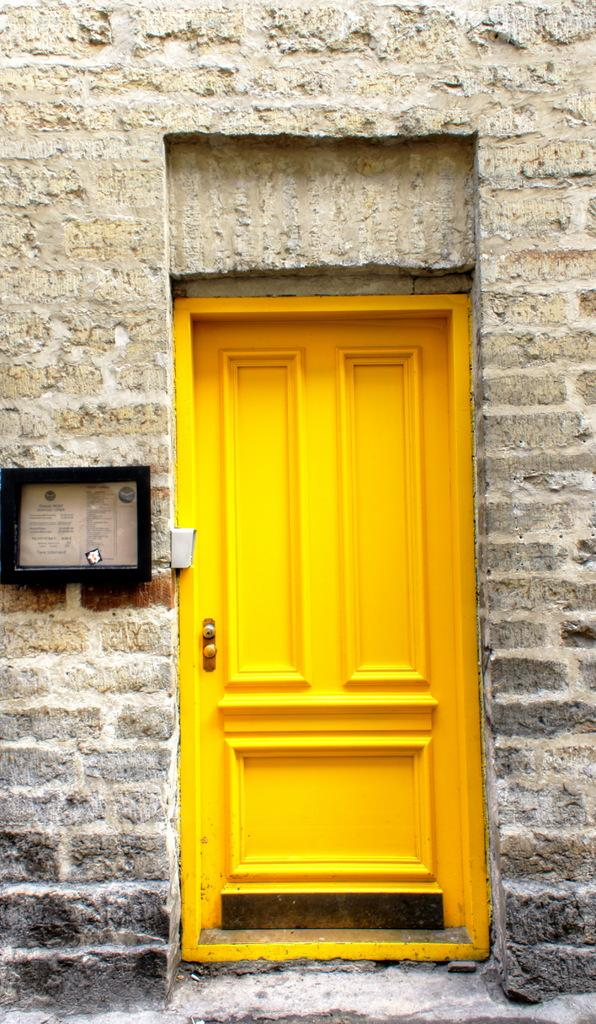What is the color and material of the door in the image? The door is a yellow color wooden door. What is the door attached to in the image? The door is attached to a brick wall. What can be seen on the wall next to the door? There is a black color box on the wall. What is inside the black box? The box contains documents. Are your friends playing the drum in the image? There is no drum or friends present in the image. How many thumbs can be seen on the door in the image? There are no thumbs visible in the image, as it features a door, a brick wall, and a black box with documents. 